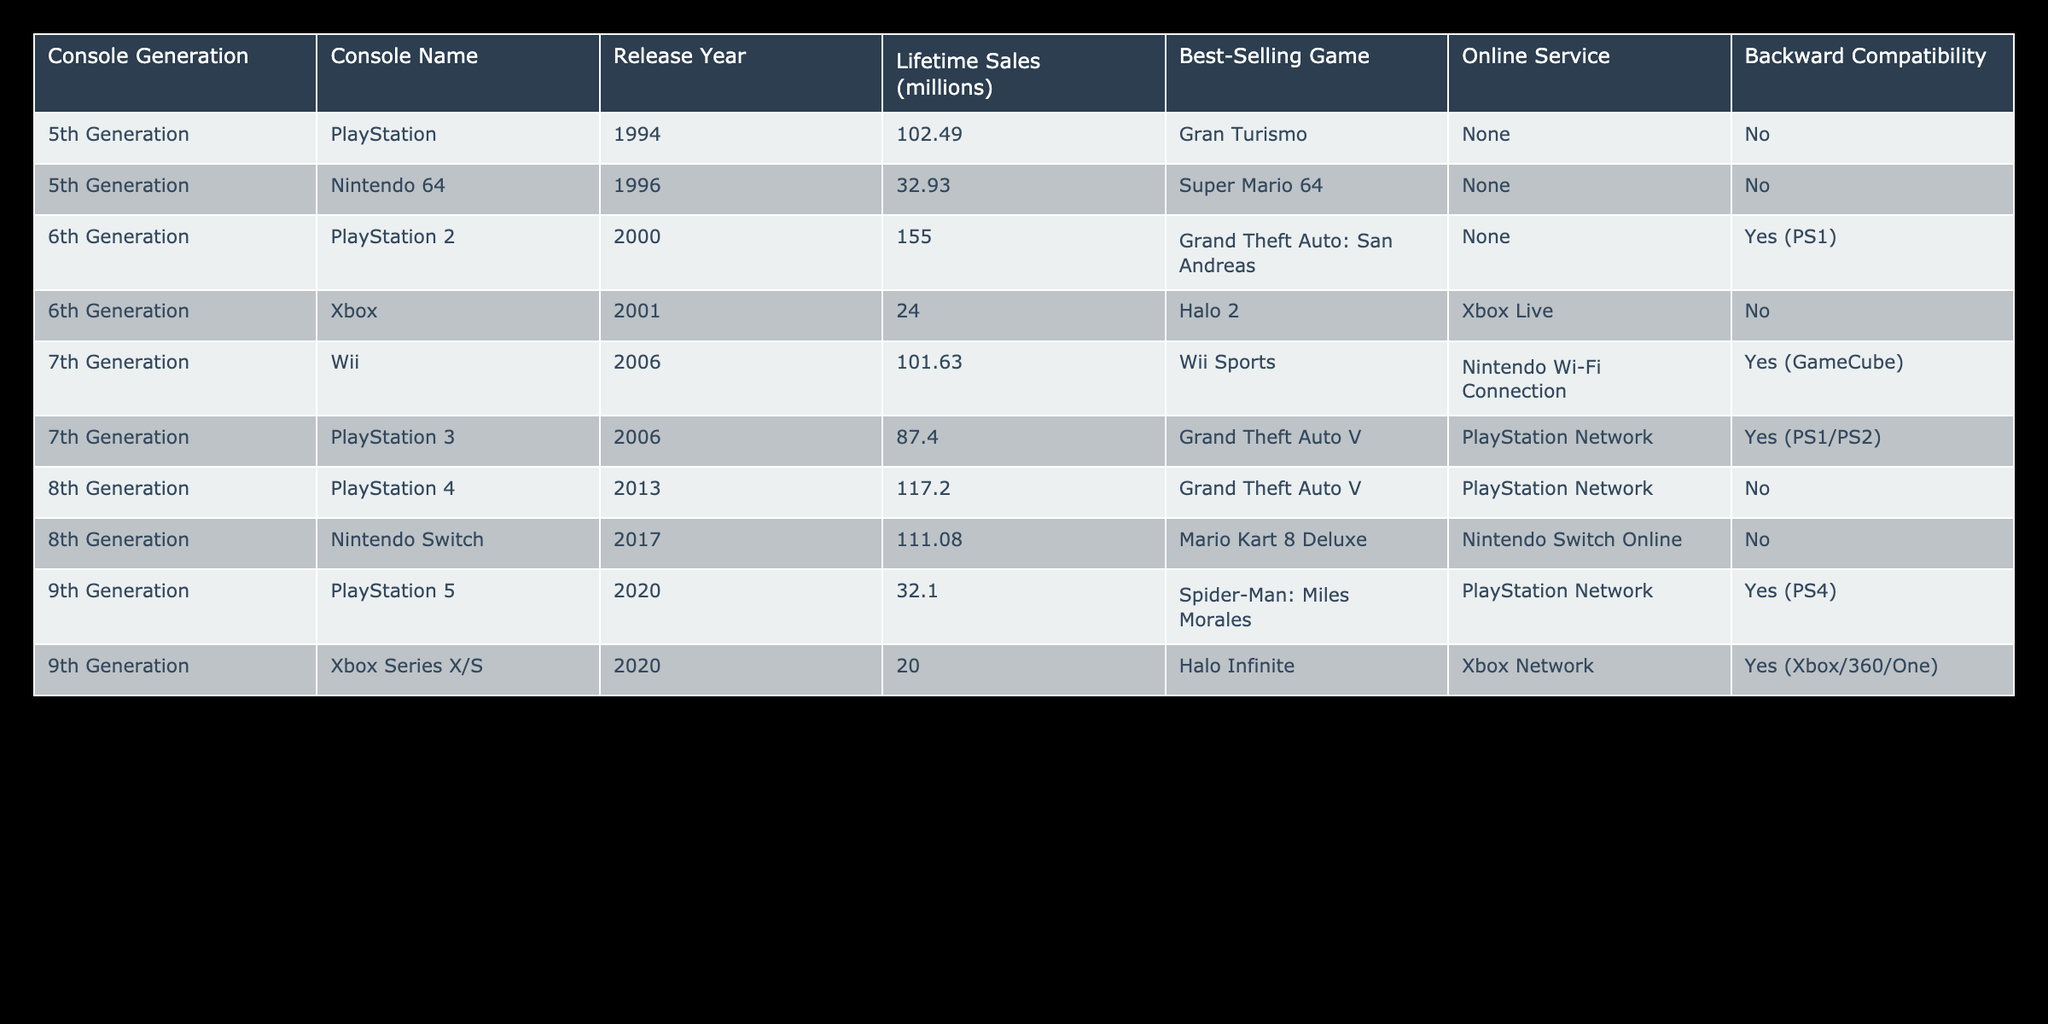What is the lifetime sales of the PlayStation 2? The table shows that the PlayStation 2 has lifetime sales of 155.0 million.
Answer: 155.0 million Which console has the best-selling game "Super Mario 64"? According to the table, the Nintendo 64 has the best-selling game "Super Mario 64".
Answer: Nintendo 64 What is the total lifetime sales of the consoles from the 6th generation? The lifetime sales of the consoles from the 6th generation are PlayStation 2 (155.0 million) and Xbox (24.0 million). Adding them gives 155.0 + 24.0 = 179.0 million.
Answer: 179.0 million Does the Wii have backward compatibility? The table indicates that the Wii does have backward compatibility with the GameCube.
Answer: Yes How many consoles have been released after 2010 with lifetime sales over 100 million? From the table, the Nintendo Switch (111.08 million) and PlayStation 4 (117.2 million) were released after 2010. There are 2 consoles fitting this description.
Answer: 2 Which generation had the highest average lifetime sales per console? To find the average for each generation: 5th Generation (PlayStation: 102.49 + Nintendo 64: 32.93 = 135.42 / 2 = 67.71), 6th Generation (PlayStation 2: 155.0 + Xbox: 24.0 = 179.0 / 2 = 89.5), 7th Generation (Wii: 101.63 + PlayStation 3: 87.4 = 189.03 / 2 = 94.515), 8th Generation (PlayStation 4: 117.2 + Nintendo Switch: 111.08 = 228.28 / 2 = 114.14), and 9th Generation (PlayStation 5: 32.1 + Xbox Series X/S: 20.0 = 52.1 / 2 = 26.05). Therefore, the 8th Generation has the highest average sales at 114.14 million.
Answer: 8th Generation Which console does not have an online service? By scanning the table, both the Nintendo 64 and Xbox do not have any online service listed.
Answer: Nintendo 64, Xbox What is the difference in lifetime sales between the PlayStation 3 and Xbox Series X/S? The lifetime sales of the PlayStation 3 is 87.4 million and Xbox Series X/S is 20.0 million. The difference is 87.4 - 20.0 = 67.4 million.
Answer: 67.4 million 